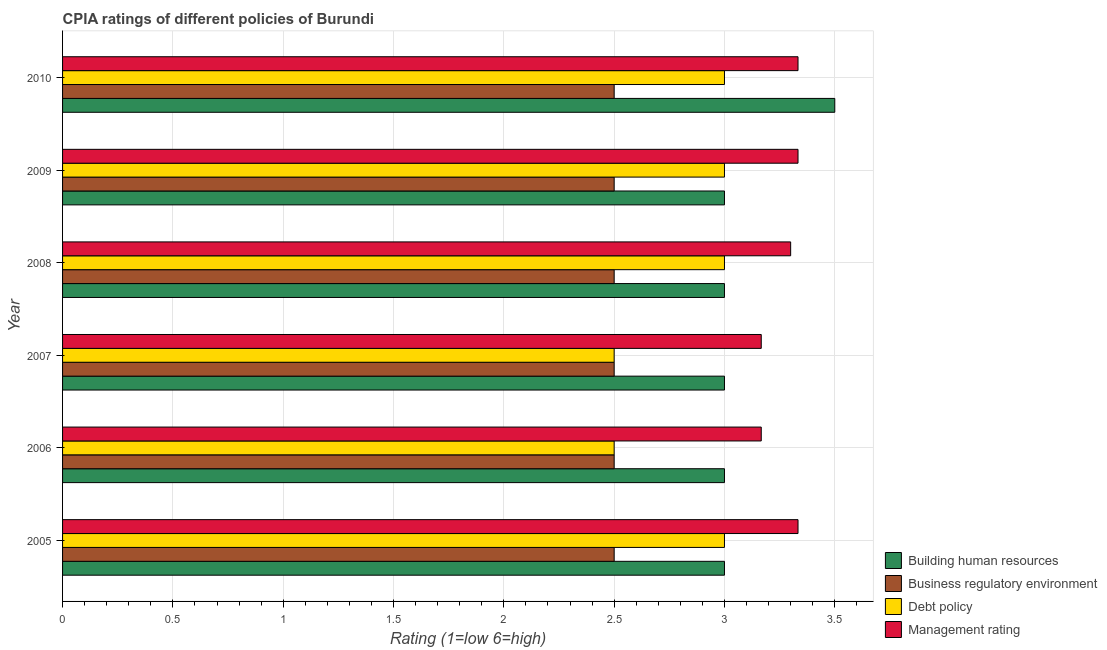Are the number of bars per tick equal to the number of legend labels?
Give a very brief answer. Yes. How many bars are there on the 5th tick from the top?
Your answer should be compact. 4. What is the label of the 6th group of bars from the top?
Keep it short and to the point. 2005. In how many cases, is the number of bars for a given year not equal to the number of legend labels?
Offer a terse response. 0. In which year was the cpia rating of debt policy maximum?
Make the answer very short. 2005. In which year was the cpia rating of building human resources minimum?
Give a very brief answer. 2005. What is the difference between the cpia rating of debt policy in 2007 and that in 2009?
Your response must be concise. -0.5. What is the average cpia rating of management per year?
Your response must be concise. 3.27. In the year 2006, what is the difference between the cpia rating of management and cpia rating of debt policy?
Make the answer very short. 0.67. In how many years, is the cpia rating of business regulatory environment greater than 3.2 ?
Keep it short and to the point. 0. What is the ratio of the cpia rating of business regulatory environment in 2005 to that in 2006?
Your answer should be very brief. 1. What is the difference between the highest and the second highest cpia rating of building human resources?
Make the answer very short. 0.5. What is the difference between the highest and the lowest cpia rating of business regulatory environment?
Give a very brief answer. 0. In how many years, is the cpia rating of debt policy greater than the average cpia rating of debt policy taken over all years?
Make the answer very short. 4. Is the sum of the cpia rating of building human resources in 2007 and 2009 greater than the maximum cpia rating of management across all years?
Keep it short and to the point. Yes. Is it the case that in every year, the sum of the cpia rating of debt policy and cpia rating of business regulatory environment is greater than the sum of cpia rating of management and cpia rating of building human resources?
Your answer should be compact. No. What does the 1st bar from the top in 2009 represents?
Keep it short and to the point. Management rating. What does the 1st bar from the bottom in 2005 represents?
Provide a succinct answer. Building human resources. Are all the bars in the graph horizontal?
Ensure brevity in your answer.  Yes. Does the graph contain any zero values?
Give a very brief answer. No. Where does the legend appear in the graph?
Ensure brevity in your answer.  Bottom right. What is the title of the graph?
Ensure brevity in your answer.  CPIA ratings of different policies of Burundi. What is the Rating (1=low 6=high) in Building human resources in 2005?
Offer a very short reply. 3. What is the Rating (1=low 6=high) in Management rating in 2005?
Your answer should be compact. 3.33. What is the Rating (1=low 6=high) in Debt policy in 2006?
Your response must be concise. 2.5. What is the Rating (1=low 6=high) of Management rating in 2006?
Give a very brief answer. 3.17. What is the Rating (1=low 6=high) of Building human resources in 2007?
Give a very brief answer. 3. What is the Rating (1=low 6=high) in Debt policy in 2007?
Offer a very short reply. 2.5. What is the Rating (1=low 6=high) of Management rating in 2007?
Provide a succinct answer. 3.17. What is the Rating (1=low 6=high) of Building human resources in 2008?
Your answer should be very brief. 3. What is the Rating (1=low 6=high) in Business regulatory environment in 2008?
Ensure brevity in your answer.  2.5. What is the Rating (1=low 6=high) in Business regulatory environment in 2009?
Keep it short and to the point. 2.5. What is the Rating (1=low 6=high) of Debt policy in 2009?
Give a very brief answer. 3. What is the Rating (1=low 6=high) of Management rating in 2009?
Your answer should be very brief. 3.33. What is the Rating (1=low 6=high) of Building human resources in 2010?
Your answer should be very brief. 3.5. What is the Rating (1=low 6=high) of Business regulatory environment in 2010?
Your answer should be very brief. 2.5. What is the Rating (1=low 6=high) in Management rating in 2010?
Your answer should be very brief. 3.33. Across all years, what is the maximum Rating (1=low 6=high) in Debt policy?
Provide a succinct answer. 3. Across all years, what is the maximum Rating (1=low 6=high) of Management rating?
Ensure brevity in your answer.  3.33. Across all years, what is the minimum Rating (1=low 6=high) in Business regulatory environment?
Your answer should be compact. 2.5. Across all years, what is the minimum Rating (1=low 6=high) in Management rating?
Ensure brevity in your answer.  3.17. What is the total Rating (1=low 6=high) of Business regulatory environment in the graph?
Keep it short and to the point. 15. What is the total Rating (1=low 6=high) in Management rating in the graph?
Your response must be concise. 19.63. What is the difference between the Rating (1=low 6=high) in Management rating in 2005 and that in 2006?
Your answer should be very brief. 0.17. What is the difference between the Rating (1=low 6=high) in Building human resources in 2005 and that in 2007?
Provide a succinct answer. 0. What is the difference between the Rating (1=low 6=high) in Debt policy in 2005 and that in 2007?
Keep it short and to the point. 0.5. What is the difference between the Rating (1=low 6=high) of Management rating in 2005 and that in 2008?
Offer a very short reply. 0.03. What is the difference between the Rating (1=low 6=high) of Building human resources in 2005 and that in 2009?
Offer a terse response. 0. What is the difference between the Rating (1=low 6=high) of Debt policy in 2005 and that in 2010?
Your answer should be very brief. 0. What is the difference between the Rating (1=low 6=high) of Building human resources in 2006 and that in 2007?
Your answer should be compact. 0. What is the difference between the Rating (1=low 6=high) of Business regulatory environment in 2006 and that in 2007?
Your response must be concise. 0. What is the difference between the Rating (1=low 6=high) of Debt policy in 2006 and that in 2007?
Your answer should be very brief. 0. What is the difference between the Rating (1=low 6=high) of Management rating in 2006 and that in 2007?
Make the answer very short. 0. What is the difference between the Rating (1=low 6=high) in Business regulatory environment in 2006 and that in 2008?
Offer a terse response. 0. What is the difference between the Rating (1=low 6=high) in Management rating in 2006 and that in 2008?
Keep it short and to the point. -0.13. What is the difference between the Rating (1=low 6=high) in Building human resources in 2006 and that in 2009?
Your answer should be very brief. 0. What is the difference between the Rating (1=low 6=high) in Debt policy in 2006 and that in 2010?
Make the answer very short. -0.5. What is the difference between the Rating (1=low 6=high) of Building human resources in 2007 and that in 2008?
Make the answer very short. 0. What is the difference between the Rating (1=low 6=high) of Business regulatory environment in 2007 and that in 2008?
Give a very brief answer. 0. What is the difference between the Rating (1=low 6=high) of Debt policy in 2007 and that in 2008?
Your response must be concise. -0.5. What is the difference between the Rating (1=low 6=high) in Management rating in 2007 and that in 2008?
Give a very brief answer. -0.13. What is the difference between the Rating (1=low 6=high) of Building human resources in 2007 and that in 2009?
Your answer should be compact. 0. What is the difference between the Rating (1=low 6=high) of Business regulatory environment in 2007 and that in 2009?
Your answer should be compact. 0. What is the difference between the Rating (1=low 6=high) in Debt policy in 2007 and that in 2009?
Keep it short and to the point. -0.5. What is the difference between the Rating (1=low 6=high) in Management rating in 2007 and that in 2009?
Keep it short and to the point. -0.17. What is the difference between the Rating (1=low 6=high) in Business regulatory environment in 2008 and that in 2009?
Ensure brevity in your answer.  0. What is the difference between the Rating (1=low 6=high) in Management rating in 2008 and that in 2009?
Ensure brevity in your answer.  -0.03. What is the difference between the Rating (1=low 6=high) in Debt policy in 2008 and that in 2010?
Offer a terse response. 0. What is the difference between the Rating (1=low 6=high) of Management rating in 2008 and that in 2010?
Ensure brevity in your answer.  -0.03. What is the difference between the Rating (1=low 6=high) in Debt policy in 2009 and that in 2010?
Your answer should be very brief. 0. What is the difference between the Rating (1=low 6=high) in Management rating in 2009 and that in 2010?
Offer a very short reply. 0. What is the difference between the Rating (1=low 6=high) in Building human resources in 2005 and the Rating (1=low 6=high) in Business regulatory environment in 2006?
Offer a very short reply. 0.5. What is the difference between the Rating (1=low 6=high) of Building human resources in 2005 and the Rating (1=low 6=high) of Debt policy in 2006?
Offer a very short reply. 0.5. What is the difference between the Rating (1=low 6=high) of Business regulatory environment in 2005 and the Rating (1=low 6=high) of Management rating in 2006?
Your answer should be very brief. -0.67. What is the difference between the Rating (1=low 6=high) of Debt policy in 2005 and the Rating (1=low 6=high) of Management rating in 2006?
Provide a short and direct response. -0.17. What is the difference between the Rating (1=low 6=high) in Building human resources in 2005 and the Rating (1=low 6=high) in Business regulatory environment in 2007?
Offer a terse response. 0.5. What is the difference between the Rating (1=low 6=high) in Building human resources in 2005 and the Rating (1=low 6=high) in Debt policy in 2007?
Offer a terse response. 0.5. What is the difference between the Rating (1=low 6=high) in Business regulatory environment in 2005 and the Rating (1=low 6=high) in Debt policy in 2007?
Ensure brevity in your answer.  0. What is the difference between the Rating (1=low 6=high) of Business regulatory environment in 2005 and the Rating (1=low 6=high) of Management rating in 2007?
Offer a very short reply. -0.67. What is the difference between the Rating (1=low 6=high) in Debt policy in 2005 and the Rating (1=low 6=high) in Management rating in 2007?
Provide a succinct answer. -0.17. What is the difference between the Rating (1=low 6=high) in Building human resources in 2005 and the Rating (1=low 6=high) in Debt policy in 2008?
Your answer should be compact. 0. What is the difference between the Rating (1=low 6=high) in Building human resources in 2005 and the Rating (1=low 6=high) in Management rating in 2008?
Provide a succinct answer. -0.3. What is the difference between the Rating (1=low 6=high) of Business regulatory environment in 2005 and the Rating (1=low 6=high) of Debt policy in 2008?
Ensure brevity in your answer.  -0.5. What is the difference between the Rating (1=low 6=high) of Business regulatory environment in 2005 and the Rating (1=low 6=high) of Management rating in 2008?
Your answer should be compact. -0.8. What is the difference between the Rating (1=low 6=high) of Building human resources in 2005 and the Rating (1=low 6=high) of Business regulatory environment in 2009?
Offer a very short reply. 0.5. What is the difference between the Rating (1=low 6=high) in Building human resources in 2005 and the Rating (1=low 6=high) in Debt policy in 2009?
Your answer should be compact. 0. What is the difference between the Rating (1=low 6=high) in Building human resources in 2005 and the Rating (1=low 6=high) in Management rating in 2009?
Offer a terse response. -0.33. What is the difference between the Rating (1=low 6=high) of Business regulatory environment in 2005 and the Rating (1=low 6=high) of Debt policy in 2009?
Your answer should be compact. -0.5. What is the difference between the Rating (1=low 6=high) of Business regulatory environment in 2005 and the Rating (1=low 6=high) of Management rating in 2009?
Make the answer very short. -0.83. What is the difference between the Rating (1=low 6=high) in Debt policy in 2005 and the Rating (1=low 6=high) in Management rating in 2009?
Give a very brief answer. -0.33. What is the difference between the Rating (1=low 6=high) in Building human resources in 2005 and the Rating (1=low 6=high) in Business regulatory environment in 2010?
Your answer should be very brief. 0.5. What is the difference between the Rating (1=low 6=high) of Building human resources in 2005 and the Rating (1=low 6=high) of Debt policy in 2010?
Your response must be concise. 0. What is the difference between the Rating (1=low 6=high) of Building human resources in 2005 and the Rating (1=low 6=high) of Management rating in 2010?
Provide a short and direct response. -0.33. What is the difference between the Rating (1=low 6=high) in Business regulatory environment in 2005 and the Rating (1=low 6=high) in Debt policy in 2010?
Offer a terse response. -0.5. What is the difference between the Rating (1=low 6=high) of Business regulatory environment in 2005 and the Rating (1=low 6=high) of Management rating in 2010?
Make the answer very short. -0.83. What is the difference between the Rating (1=low 6=high) in Building human resources in 2006 and the Rating (1=low 6=high) in Business regulatory environment in 2007?
Provide a short and direct response. 0.5. What is the difference between the Rating (1=low 6=high) in Building human resources in 2006 and the Rating (1=low 6=high) in Debt policy in 2007?
Ensure brevity in your answer.  0.5. What is the difference between the Rating (1=low 6=high) in Building human resources in 2006 and the Rating (1=low 6=high) in Management rating in 2007?
Keep it short and to the point. -0.17. What is the difference between the Rating (1=low 6=high) in Business regulatory environment in 2006 and the Rating (1=low 6=high) in Debt policy in 2007?
Offer a terse response. 0. What is the difference between the Rating (1=low 6=high) of Business regulatory environment in 2006 and the Rating (1=low 6=high) of Management rating in 2007?
Your response must be concise. -0.67. What is the difference between the Rating (1=low 6=high) of Debt policy in 2006 and the Rating (1=low 6=high) of Management rating in 2007?
Offer a very short reply. -0.67. What is the difference between the Rating (1=low 6=high) of Building human resources in 2006 and the Rating (1=low 6=high) of Business regulatory environment in 2008?
Ensure brevity in your answer.  0.5. What is the difference between the Rating (1=low 6=high) of Building human resources in 2006 and the Rating (1=low 6=high) of Management rating in 2008?
Provide a succinct answer. -0.3. What is the difference between the Rating (1=low 6=high) of Debt policy in 2006 and the Rating (1=low 6=high) of Management rating in 2008?
Your response must be concise. -0.8. What is the difference between the Rating (1=low 6=high) in Building human resources in 2006 and the Rating (1=low 6=high) in Business regulatory environment in 2009?
Keep it short and to the point. 0.5. What is the difference between the Rating (1=low 6=high) of Building human resources in 2006 and the Rating (1=low 6=high) of Debt policy in 2009?
Provide a short and direct response. 0. What is the difference between the Rating (1=low 6=high) of Building human resources in 2006 and the Rating (1=low 6=high) of Management rating in 2009?
Provide a succinct answer. -0.33. What is the difference between the Rating (1=low 6=high) in Business regulatory environment in 2006 and the Rating (1=low 6=high) in Debt policy in 2009?
Ensure brevity in your answer.  -0.5. What is the difference between the Rating (1=low 6=high) in Building human resources in 2006 and the Rating (1=low 6=high) in Business regulatory environment in 2010?
Your response must be concise. 0.5. What is the difference between the Rating (1=low 6=high) in Building human resources in 2006 and the Rating (1=low 6=high) in Management rating in 2010?
Make the answer very short. -0.33. What is the difference between the Rating (1=low 6=high) of Debt policy in 2006 and the Rating (1=low 6=high) of Management rating in 2010?
Give a very brief answer. -0.83. What is the difference between the Rating (1=low 6=high) of Building human resources in 2007 and the Rating (1=low 6=high) of Business regulatory environment in 2008?
Your answer should be very brief. 0.5. What is the difference between the Rating (1=low 6=high) of Building human resources in 2007 and the Rating (1=low 6=high) of Management rating in 2008?
Your response must be concise. -0.3. What is the difference between the Rating (1=low 6=high) of Business regulatory environment in 2007 and the Rating (1=low 6=high) of Management rating in 2008?
Offer a terse response. -0.8. What is the difference between the Rating (1=low 6=high) of Building human resources in 2007 and the Rating (1=low 6=high) of Debt policy in 2009?
Provide a succinct answer. 0. What is the difference between the Rating (1=low 6=high) in Building human resources in 2007 and the Rating (1=low 6=high) in Management rating in 2009?
Give a very brief answer. -0.33. What is the difference between the Rating (1=low 6=high) in Business regulatory environment in 2007 and the Rating (1=low 6=high) in Debt policy in 2009?
Your response must be concise. -0.5. What is the difference between the Rating (1=low 6=high) in Business regulatory environment in 2007 and the Rating (1=low 6=high) in Management rating in 2009?
Keep it short and to the point. -0.83. What is the difference between the Rating (1=low 6=high) of Building human resources in 2007 and the Rating (1=low 6=high) of Management rating in 2010?
Offer a terse response. -0.33. What is the difference between the Rating (1=low 6=high) in Building human resources in 2008 and the Rating (1=low 6=high) in Business regulatory environment in 2009?
Your answer should be very brief. 0.5. What is the difference between the Rating (1=low 6=high) in Building human resources in 2008 and the Rating (1=low 6=high) in Debt policy in 2009?
Your response must be concise. 0. What is the difference between the Rating (1=low 6=high) in Building human resources in 2008 and the Rating (1=low 6=high) in Management rating in 2009?
Provide a succinct answer. -0.33. What is the difference between the Rating (1=low 6=high) of Business regulatory environment in 2008 and the Rating (1=low 6=high) of Debt policy in 2009?
Your answer should be very brief. -0.5. What is the difference between the Rating (1=low 6=high) in Debt policy in 2008 and the Rating (1=low 6=high) in Management rating in 2009?
Your response must be concise. -0.33. What is the difference between the Rating (1=low 6=high) in Building human resources in 2008 and the Rating (1=low 6=high) in Business regulatory environment in 2010?
Your response must be concise. 0.5. What is the difference between the Rating (1=low 6=high) in Business regulatory environment in 2008 and the Rating (1=low 6=high) in Debt policy in 2010?
Make the answer very short. -0.5. What is the difference between the Rating (1=low 6=high) in Debt policy in 2008 and the Rating (1=low 6=high) in Management rating in 2010?
Offer a very short reply. -0.33. What is the difference between the Rating (1=low 6=high) in Business regulatory environment in 2009 and the Rating (1=low 6=high) in Debt policy in 2010?
Ensure brevity in your answer.  -0.5. What is the difference between the Rating (1=low 6=high) in Business regulatory environment in 2009 and the Rating (1=low 6=high) in Management rating in 2010?
Ensure brevity in your answer.  -0.83. What is the average Rating (1=low 6=high) in Building human resources per year?
Provide a short and direct response. 3.08. What is the average Rating (1=low 6=high) of Business regulatory environment per year?
Ensure brevity in your answer.  2.5. What is the average Rating (1=low 6=high) in Debt policy per year?
Ensure brevity in your answer.  2.83. What is the average Rating (1=low 6=high) in Management rating per year?
Your answer should be compact. 3.27. In the year 2005, what is the difference between the Rating (1=low 6=high) in Building human resources and Rating (1=low 6=high) in Debt policy?
Keep it short and to the point. 0. In the year 2005, what is the difference between the Rating (1=low 6=high) in Business regulatory environment and Rating (1=low 6=high) in Debt policy?
Make the answer very short. -0.5. In the year 2005, what is the difference between the Rating (1=low 6=high) in Business regulatory environment and Rating (1=low 6=high) in Management rating?
Your answer should be very brief. -0.83. In the year 2006, what is the difference between the Rating (1=low 6=high) of Building human resources and Rating (1=low 6=high) of Business regulatory environment?
Offer a terse response. 0.5. In the year 2006, what is the difference between the Rating (1=low 6=high) of Building human resources and Rating (1=low 6=high) of Debt policy?
Provide a succinct answer. 0.5. In the year 2006, what is the difference between the Rating (1=low 6=high) of Business regulatory environment and Rating (1=low 6=high) of Debt policy?
Your response must be concise. 0. In the year 2006, what is the difference between the Rating (1=low 6=high) of Debt policy and Rating (1=low 6=high) of Management rating?
Offer a very short reply. -0.67. In the year 2007, what is the difference between the Rating (1=low 6=high) in Building human resources and Rating (1=low 6=high) in Business regulatory environment?
Your answer should be very brief. 0.5. In the year 2008, what is the difference between the Rating (1=low 6=high) of Building human resources and Rating (1=low 6=high) of Management rating?
Give a very brief answer. -0.3. In the year 2008, what is the difference between the Rating (1=low 6=high) of Business regulatory environment and Rating (1=low 6=high) of Management rating?
Keep it short and to the point. -0.8. In the year 2008, what is the difference between the Rating (1=low 6=high) in Debt policy and Rating (1=low 6=high) in Management rating?
Provide a short and direct response. -0.3. In the year 2009, what is the difference between the Rating (1=low 6=high) of Building human resources and Rating (1=low 6=high) of Business regulatory environment?
Give a very brief answer. 0.5. In the year 2009, what is the difference between the Rating (1=low 6=high) of Building human resources and Rating (1=low 6=high) of Management rating?
Your response must be concise. -0.33. In the year 2009, what is the difference between the Rating (1=low 6=high) of Business regulatory environment and Rating (1=low 6=high) of Management rating?
Provide a short and direct response. -0.83. In the year 2010, what is the difference between the Rating (1=low 6=high) of Building human resources and Rating (1=low 6=high) of Debt policy?
Offer a terse response. 0.5. In the year 2010, what is the difference between the Rating (1=low 6=high) of Building human resources and Rating (1=low 6=high) of Management rating?
Your answer should be very brief. 0.17. In the year 2010, what is the difference between the Rating (1=low 6=high) in Business regulatory environment and Rating (1=low 6=high) in Management rating?
Give a very brief answer. -0.83. In the year 2010, what is the difference between the Rating (1=low 6=high) of Debt policy and Rating (1=low 6=high) of Management rating?
Ensure brevity in your answer.  -0.33. What is the ratio of the Rating (1=low 6=high) in Building human resources in 2005 to that in 2006?
Give a very brief answer. 1. What is the ratio of the Rating (1=low 6=high) in Business regulatory environment in 2005 to that in 2006?
Your answer should be very brief. 1. What is the ratio of the Rating (1=low 6=high) in Management rating in 2005 to that in 2006?
Provide a short and direct response. 1.05. What is the ratio of the Rating (1=low 6=high) of Building human resources in 2005 to that in 2007?
Ensure brevity in your answer.  1. What is the ratio of the Rating (1=low 6=high) of Business regulatory environment in 2005 to that in 2007?
Your answer should be compact. 1. What is the ratio of the Rating (1=low 6=high) of Debt policy in 2005 to that in 2007?
Ensure brevity in your answer.  1.2. What is the ratio of the Rating (1=low 6=high) in Management rating in 2005 to that in 2007?
Keep it short and to the point. 1.05. What is the ratio of the Rating (1=low 6=high) in Building human resources in 2005 to that in 2009?
Offer a very short reply. 1. What is the ratio of the Rating (1=low 6=high) in Business regulatory environment in 2005 to that in 2009?
Your answer should be very brief. 1. What is the ratio of the Rating (1=low 6=high) of Debt policy in 2005 to that in 2009?
Offer a terse response. 1. What is the ratio of the Rating (1=low 6=high) of Management rating in 2005 to that in 2009?
Your answer should be very brief. 1. What is the ratio of the Rating (1=low 6=high) of Debt policy in 2005 to that in 2010?
Your answer should be compact. 1. What is the ratio of the Rating (1=low 6=high) in Building human resources in 2006 to that in 2007?
Your answer should be compact. 1. What is the ratio of the Rating (1=low 6=high) of Building human resources in 2006 to that in 2008?
Offer a very short reply. 1. What is the ratio of the Rating (1=low 6=high) of Business regulatory environment in 2006 to that in 2008?
Give a very brief answer. 1. What is the ratio of the Rating (1=low 6=high) of Management rating in 2006 to that in 2008?
Make the answer very short. 0.96. What is the ratio of the Rating (1=low 6=high) of Management rating in 2006 to that in 2009?
Make the answer very short. 0.95. What is the ratio of the Rating (1=low 6=high) in Building human resources in 2006 to that in 2010?
Make the answer very short. 0.86. What is the ratio of the Rating (1=low 6=high) of Management rating in 2006 to that in 2010?
Keep it short and to the point. 0.95. What is the ratio of the Rating (1=low 6=high) in Building human resources in 2007 to that in 2008?
Your answer should be compact. 1. What is the ratio of the Rating (1=low 6=high) in Business regulatory environment in 2007 to that in 2008?
Your response must be concise. 1. What is the ratio of the Rating (1=low 6=high) in Management rating in 2007 to that in 2008?
Keep it short and to the point. 0.96. What is the ratio of the Rating (1=low 6=high) of Building human resources in 2007 to that in 2009?
Provide a short and direct response. 1. What is the ratio of the Rating (1=low 6=high) of Management rating in 2007 to that in 2009?
Your response must be concise. 0.95. What is the ratio of the Rating (1=low 6=high) of Debt policy in 2007 to that in 2010?
Provide a succinct answer. 0.83. What is the ratio of the Rating (1=low 6=high) in Management rating in 2007 to that in 2010?
Provide a succinct answer. 0.95. What is the ratio of the Rating (1=low 6=high) of Building human resources in 2008 to that in 2009?
Your answer should be compact. 1. What is the ratio of the Rating (1=low 6=high) in Debt policy in 2008 to that in 2010?
Provide a short and direct response. 1. What is the ratio of the Rating (1=low 6=high) of Management rating in 2008 to that in 2010?
Provide a succinct answer. 0.99. What is the ratio of the Rating (1=low 6=high) of Building human resources in 2009 to that in 2010?
Ensure brevity in your answer.  0.86. What is the ratio of the Rating (1=low 6=high) of Management rating in 2009 to that in 2010?
Ensure brevity in your answer.  1. What is the difference between the highest and the second highest Rating (1=low 6=high) in Building human resources?
Ensure brevity in your answer.  0.5. What is the difference between the highest and the second highest Rating (1=low 6=high) in Debt policy?
Provide a short and direct response. 0. What is the difference between the highest and the second highest Rating (1=low 6=high) in Management rating?
Your answer should be very brief. 0. What is the difference between the highest and the lowest Rating (1=low 6=high) in Building human resources?
Give a very brief answer. 0.5. What is the difference between the highest and the lowest Rating (1=low 6=high) of Business regulatory environment?
Provide a succinct answer. 0. What is the difference between the highest and the lowest Rating (1=low 6=high) in Management rating?
Your answer should be compact. 0.17. 